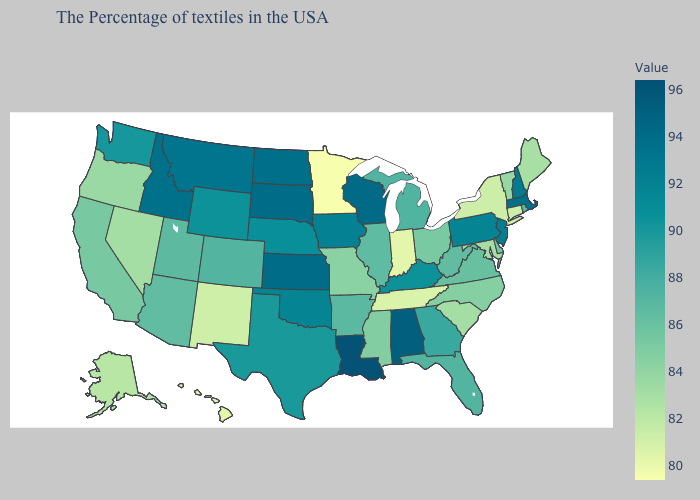Does Utah have a lower value than Montana?
Give a very brief answer. Yes. Which states have the lowest value in the USA?
Be succinct. Minnesota. Among the states that border Colorado , which have the highest value?
Give a very brief answer. Kansas. Does Wisconsin have the highest value in the MidWest?
Write a very short answer. Yes. Is the legend a continuous bar?
Be succinct. Yes. 